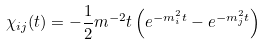Convert formula to latex. <formula><loc_0><loc_0><loc_500><loc_500>\chi _ { i j } ( t ) = - \frac { 1 } { 2 } m ^ { - 2 } t \left ( e ^ { - m _ { i } ^ { 2 } t } - e ^ { - m _ { j } ^ { 2 } t } \right )</formula> 